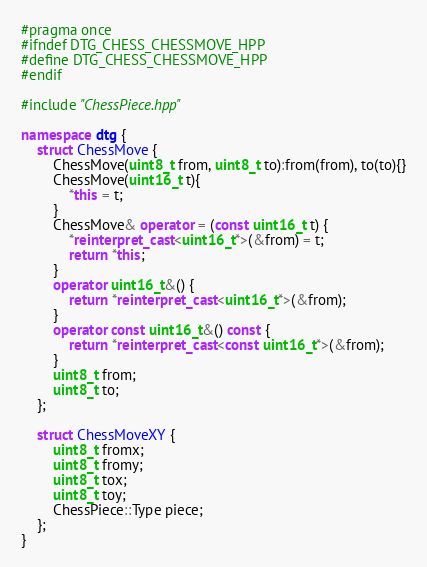Convert code to text. <code><loc_0><loc_0><loc_500><loc_500><_C++_>#pragma once
#ifndef DTG_CHESS_CHESSMOVE_HPP
#define DTG_CHESS_CHESSMOVE_HPP
#endif

#include "ChessPiece.hpp"

namespace dtg {
	struct ChessMove {
		ChessMove(uint8_t from, uint8_t to):from(from), to(to){}
		ChessMove(uint16_t t){
			*this = t;	
		}
		ChessMove& operator = (const uint16_t t) {
			*reinterpret_cast<uint16_t*>(&from) = t;
			return *this;
		}
		operator uint16_t&() {
			return *reinterpret_cast<uint16_t*>(&from);
		}
		operator const uint16_t&() const {
			return *reinterpret_cast<const uint16_t*>(&from);
		}
		uint8_t from;
		uint8_t to;
	};

	struct ChessMoveXY {
		uint8_t fromx;
		uint8_t fromy;
		uint8_t tox;
		uint8_t toy;
		ChessPiece::Type piece;
	};
}
</code> 